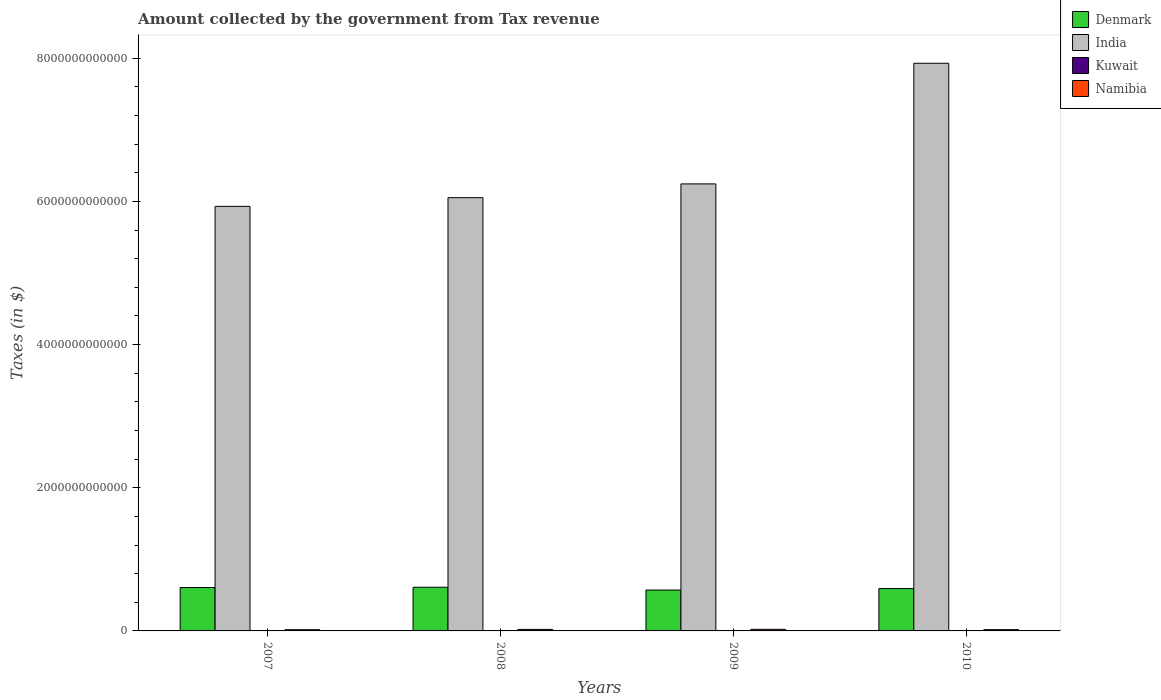How many groups of bars are there?
Give a very brief answer. 4. Are the number of bars per tick equal to the number of legend labels?
Your answer should be very brief. Yes. Are the number of bars on each tick of the X-axis equal?
Offer a very short reply. Yes. How many bars are there on the 2nd tick from the right?
Give a very brief answer. 4. What is the label of the 1st group of bars from the left?
Offer a terse response. 2007. In how many cases, is the number of bars for a given year not equal to the number of legend labels?
Your response must be concise. 0. What is the amount collected by the government from tax revenue in Kuwait in 2007?
Make the answer very short. 3.54e+08. Across all years, what is the maximum amount collected by the government from tax revenue in India?
Your response must be concise. 7.93e+12. Across all years, what is the minimum amount collected by the government from tax revenue in Kuwait?
Give a very brief answer. 2.96e+08. What is the total amount collected by the government from tax revenue in Kuwait in the graph?
Ensure brevity in your answer.  1.32e+09. What is the difference between the amount collected by the government from tax revenue in Namibia in 2007 and that in 2010?
Your answer should be compact. -9.67e+08. What is the difference between the amount collected by the government from tax revenue in Denmark in 2008 and the amount collected by the government from tax revenue in Namibia in 2010?
Provide a short and direct response. 5.92e+11. What is the average amount collected by the government from tax revenue in Namibia per year?
Provide a short and direct response. 1.96e+1. In the year 2008, what is the difference between the amount collected by the government from tax revenue in Kuwait and amount collected by the government from tax revenue in India?
Keep it short and to the point. -6.05e+12. In how many years, is the amount collected by the government from tax revenue in Namibia greater than 2000000000000 $?
Ensure brevity in your answer.  0. What is the ratio of the amount collected by the government from tax revenue in Denmark in 2008 to that in 2010?
Give a very brief answer. 1.03. Is the difference between the amount collected by the government from tax revenue in Kuwait in 2009 and 2010 greater than the difference between the amount collected by the government from tax revenue in India in 2009 and 2010?
Provide a succinct answer. Yes. What is the difference between the highest and the second highest amount collected by the government from tax revenue in Namibia?
Your answer should be very brief. 1.05e+09. What is the difference between the highest and the lowest amount collected by the government from tax revenue in India?
Your answer should be compact. 2.00e+12. What does the 3rd bar from the left in 2009 represents?
Provide a succinct answer. Kuwait. Are all the bars in the graph horizontal?
Ensure brevity in your answer.  No. What is the difference between two consecutive major ticks on the Y-axis?
Give a very brief answer. 2.00e+12. Does the graph contain grids?
Make the answer very short. No. How many legend labels are there?
Your answer should be compact. 4. What is the title of the graph?
Ensure brevity in your answer.  Amount collected by the government from Tax revenue. What is the label or title of the Y-axis?
Provide a succinct answer. Taxes (in $). What is the Taxes (in $) in Denmark in 2007?
Provide a succinct answer. 6.07e+11. What is the Taxes (in $) in India in 2007?
Keep it short and to the point. 5.93e+12. What is the Taxes (in $) in Kuwait in 2007?
Your answer should be very brief. 3.54e+08. What is the Taxes (in $) of Namibia in 2007?
Offer a very short reply. 1.70e+1. What is the Taxes (in $) in Denmark in 2008?
Offer a terse response. 6.10e+11. What is the Taxes (in $) of India in 2008?
Offer a very short reply. 6.05e+12. What is the Taxes (in $) in Kuwait in 2008?
Offer a terse response. 3.47e+08. What is the Taxes (in $) in Namibia in 2008?
Your answer should be very brief. 2.12e+1. What is the Taxes (in $) of Denmark in 2009?
Ensure brevity in your answer.  5.71e+11. What is the Taxes (in $) in India in 2009?
Provide a short and direct response. 6.25e+12. What is the Taxes (in $) in Kuwait in 2009?
Make the answer very short. 2.96e+08. What is the Taxes (in $) of Namibia in 2009?
Provide a short and direct response. 2.23e+1. What is the Taxes (in $) of Denmark in 2010?
Your response must be concise. 5.91e+11. What is the Taxes (in $) of India in 2010?
Make the answer very short. 7.93e+12. What is the Taxes (in $) in Kuwait in 2010?
Offer a terse response. 3.24e+08. What is the Taxes (in $) in Namibia in 2010?
Keep it short and to the point. 1.79e+1. Across all years, what is the maximum Taxes (in $) of Denmark?
Make the answer very short. 6.10e+11. Across all years, what is the maximum Taxes (in $) of India?
Your response must be concise. 7.93e+12. Across all years, what is the maximum Taxes (in $) of Kuwait?
Keep it short and to the point. 3.54e+08. Across all years, what is the maximum Taxes (in $) of Namibia?
Ensure brevity in your answer.  2.23e+1. Across all years, what is the minimum Taxes (in $) of Denmark?
Your answer should be compact. 5.71e+11. Across all years, what is the minimum Taxes (in $) in India?
Your answer should be very brief. 5.93e+12. Across all years, what is the minimum Taxes (in $) of Kuwait?
Your response must be concise. 2.96e+08. Across all years, what is the minimum Taxes (in $) in Namibia?
Offer a very short reply. 1.70e+1. What is the total Taxes (in $) in Denmark in the graph?
Make the answer very short. 2.38e+12. What is the total Taxes (in $) of India in the graph?
Offer a terse response. 2.62e+13. What is the total Taxes (in $) of Kuwait in the graph?
Give a very brief answer. 1.32e+09. What is the total Taxes (in $) of Namibia in the graph?
Your answer should be compact. 7.84e+1. What is the difference between the Taxes (in $) in Denmark in 2007 and that in 2008?
Your response must be concise. -3.56e+09. What is the difference between the Taxes (in $) of India in 2007 and that in 2008?
Ensure brevity in your answer.  -1.22e+11. What is the difference between the Taxes (in $) in Namibia in 2007 and that in 2008?
Keep it short and to the point. -4.25e+09. What is the difference between the Taxes (in $) of Denmark in 2007 and that in 2009?
Keep it short and to the point. 3.54e+1. What is the difference between the Taxes (in $) of India in 2007 and that in 2009?
Ensure brevity in your answer.  -3.14e+11. What is the difference between the Taxes (in $) in Kuwait in 2007 and that in 2009?
Offer a very short reply. 5.80e+07. What is the difference between the Taxes (in $) in Namibia in 2007 and that in 2009?
Your answer should be very brief. -5.30e+09. What is the difference between the Taxes (in $) of Denmark in 2007 and that in 2010?
Offer a terse response. 1.51e+1. What is the difference between the Taxes (in $) of India in 2007 and that in 2010?
Keep it short and to the point. -2.00e+12. What is the difference between the Taxes (in $) in Kuwait in 2007 and that in 2010?
Provide a short and direct response. 3.00e+07. What is the difference between the Taxes (in $) of Namibia in 2007 and that in 2010?
Make the answer very short. -9.67e+08. What is the difference between the Taxes (in $) in Denmark in 2008 and that in 2009?
Ensure brevity in your answer.  3.89e+1. What is the difference between the Taxes (in $) of India in 2008 and that in 2009?
Provide a short and direct response. -1.92e+11. What is the difference between the Taxes (in $) in Kuwait in 2008 and that in 2009?
Provide a succinct answer. 5.10e+07. What is the difference between the Taxes (in $) in Namibia in 2008 and that in 2009?
Your response must be concise. -1.05e+09. What is the difference between the Taxes (in $) in Denmark in 2008 and that in 2010?
Provide a succinct answer. 1.87e+1. What is the difference between the Taxes (in $) of India in 2008 and that in 2010?
Keep it short and to the point. -1.88e+12. What is the difference between the Taxes (in $) of Kuwait in 2008 and that in 2010?
Provide a succinct answer. 2.30e+07. What is the difference between the Taxes (in $) of Namibia in 2008 and that in 2010?
Provide a short and direct response. 3.29e+09. What is the difference between the Taxes (in $) of Denmark in 2009 and that in 2010?
Provide a short and direct response. -2.03e+1. What is the difference between the Taxes (in $) in India in 2009 and that in 2010?
Your answer should be compact. -1.69e+12. What is the difference between the Taxes (in $) in Kuwait in 2009 and that in 2010?
Make the answer very short. -2.80e+07. What is the difference between the Taxes (in $) of Namibia in 2009 and that in 2010?
Give a very brief answer. 4.34e+09. What is the difference between the Taxes (in $) in Denmark in 2007 and the Taxes (in $) in India in 2008?
Keep it short and to the point. -5.45e+12. What is the difference between the Taxes (in $) of Denmark in 2007 and the Taxes (in $) of Kuwait in 2008?
Your answer should be very brief. 6.06e+11. What is the difference between the Taxes (in $) of Denmark in 2007 and the Taxes (in $) of Namibia in 2008?
Give a very brief answer. 5.85e+11. What is the difference between the Taxes (in $) in India in 2007 and the Taxes (in $) in Kuwait in 2008?
Provide a succinct answer. 5.93e+12. What is the difference between the Taxes (in $) in India in 2007 and the Taxes (in $) in Namibia in 2008?
Keep it short and to the point. 5.91e+12. What is the difference between the Taxes (in $) in Kuwait in 2007 and the Taxes (in $) in Namibia in 2008?
Ensure brevity in your answer.  -2.09e+1. What is the difference between the Taxes (in $) of Denmark in 2007 and the Taxes (in $) of India in 2009?
Provide a succinct answer. -5.64e+12. What is the difference between the Taxes (in $) of Denmark in 2007 and the Taxes (in $) of Kuwait in 2009?
Your response must be concise. 6.06e+11. What is the difference between the Taxes (in $) in Denmark in 2007 and the Taxes (in $) in Namibia in 2009?
Keep it short and to the point. 5.84e+11. What is the difference between the Taxes (in $) of India in 2007 and the Taxes (in $) of Kuwait in 2009?
Your response must be concise. 5.93e+12. What is the difference between the Taxes (in $) in India in 2007 and the Taxes (in $) in Namibia in 2009?
Your answer should be very brief. 5.91e+12. What is the difference between the Taxes (in $) of Kuwait in 2007 and the Taxes (in $) of Namibia in 2009?
Provide a succinct answer. -2.19e+1. What is the difference between the Taxes (in $) in Denmark in 2007 and the Taxes (in $) in India in 2010?
Ensure brevity in your answer.  -7.32e+12. What is the difference between the Taxes (in $) of Denmark in 2007 and the Taxes (in $) of Kuwait in 2010?
Your response must be concise. 6.06e+11. What is the difference between the Taxes (in $) in Denmark in 2007 and the Taxes (in $) in Namibia in 2010?
Your answer should be very brief. 5.89e+11. What is the difference between the Taxes (in $) in India in 2007 and the Taxes (in $) in Kuwait in 2010?
Give a very brief answer. 5.93e+12. What is the difference between the Taxes (in $) in India in 2007 and the Taxes (in $) in Namibia in 2010?
Provide a short and direct response. 5.91e+12. What is the difference between the Taxes (in $) of Kuwait in 2007 and the Taxes (in $) of Namibia in 2010?
Make the answer very short. -1.76e+1. What is the difference between the Taxes (in $) in Denmark in 2008 and the Taxes (in $) in India in 2009?
Give a very brief answer. -5.64e+12. What is the difference between the Taxes (in $) in Denmark in 2008 and the Taxes (in $) in Kuwait in 2009?
Ensure brevity in your answer.  6.10e+11. What is the difference between the Taxes (in $) of Denmark in 2008 and the Taxes (in $) of Namibia in 2009?
Offer a terse response. 5.88e+11. What is the difference between the Taxes (in $) in India in 2008 and the Taxes (in $) in Kuwait in 2009?
Give a very brief answer. 6.05e+12. What is the difference between the Taxes (in $) of India in 2008 and the Taxes (in $) of Namibia in 2009?
Your answer should be compact. 6.03e+12. What is the difference between the Taxes (in $) of Kuwait in 2008 and the Taxes (in $) of Namibia in 2009?
Offer a very short reply. -2.19e+1. What is the difference between the Taxes (in $) in Denmark in 2008 and the Taxes (in $) in India in 2010?
Your answer should be compact. -7.32e+12. What is the difference between the Taxes (in $) of Denmark in 2008 and the Taxes (in $) of Kuwait in 2010?
Your response must be concise. 6.10e+11. What is the difference between the Taxes (in $) of Denmark in 2008 and the Taxes (in $) of Namibia in 2010?
Provide a short and direct response. 5.92e+11. What is the difference between the Taxes (in $) of India in 2008 and the Taxes (in $) of Kuwait in 2010?
Provide a succinct answer. 6.05e+12. What is the difference between the Taxes (in $) in India in 2008 and the Taxes (in $) in Namibia in 2010?
Your answer should be compact. 6.04e+12. What is the difference between the Taxes (in $) in Kuwait in 2008 and the Taxes (in $) in Namibia in 2010?
Make the answer very short. -1.76e+1. What is the difference between the Taxes (in $) of Denmark in 2009 and the Taxes (in $) of India in 2010?
Your answer should be very brief. -7.36e+12. What is the difference between the Taxes (in $) in Denmark in 2009 and the Taxes (in $) in Kuwait in 2010?
Your response must be concise. 5.71e+11. What is the difference between the Taxes (in $) in Denmark in 2009 and the Taxes (in $) in Namibia in 2010?
Your answer should be very brief. 5.53e+11. What is the difference between the Taxes (in $) in India in 2009 and the Taxes (in $) in Kuwait in 2010?
Your answer should be compact. 6.24e+12. What is the difference between the Taxes (in $) of India in 2009 and the Taxes (in $) of Namibia in 2010?
Keep it short and to the point. 6.23e+12. What is the difference between the Taxes (in $) in Kuwait in 2009 and the Taxes (in $) in Namibia in 2010?
Keep it short and to the point. -1.76e+1. What is the average Taxes (in $) of Denmark per year?
Your response must be concise. 5.95e+11. What is the average Taxes (in $) of India per year?
Your response must be concise. 6.54e+12. What is the average Taxes (in $) in Kuwait per year?
Provide a short and direct response. 3.30e+08. What is the average Taxes (in $) in Namibia per year?
Provide a succinct answer. 1.96e+1. In the year 2007, what is the difference between the Taxes (in $) of Denmark and Taxes (in $) of India?
Offer a very short reply. -5.32e+12. In the year 2007, what is the difference between the Taxes (in $) in Denmark and Taxes (in $) in Kuwait?
Make the answer very short. 6.06e+11. In the year 2007, what is the difference between the Taxes (in $) in Denmark and Taxes (in $) in Namibia?
Give a very brief answer. 5.90e+11. In the year 2007, what is the difference between the Taxes (in $) of India and Taxes (in $) of Kuwait?
Provide a short and direct response. 5.93e+12. In the year 2007, what is the difference between the Taxes (in $) in India and Taxes (in $) in Namibia?
Ensure brevity in your answer.  5.91e+12. In the year 2007, what is the difference between the Taxes (in $) of Kuwait and Taxes (in $) of Namibia?
Give a very brief answer. -1.66e+1. In the year 2008, what is the difference between the Taxes (in $) of Denmark and Taxes (in $) of India?
Your answer should be very brief. -5.44e+12. In the year 2008, what is the difference between the Taxes (in $) of Denmark and Taxes (in $) of Kuwait?
Offer a very short reply. 6.10e+11. In the year 2008, what is the difference between the Taxes (in $) in Denmark and Taxes (in $) in Namibia?
Your response must be concise. 5.89e+11. In the year 2008, what is the difference between the Taxes (in $) of India and Taxes (in $) of Kuwait?
Offer a very short reply. 6.05e+12. In the year 2008, what is the difference between the Taxes (in $) of India and Taxes (in $) of Namibia?
Provide a succinct answer. 6.03e+12. In the year 2008, what is the difference between the Taxes (in $) of Kuwait and Taxes (in $) of Namibia?
Offer a very short reply. -2.09e+1. In the year 2009, what is the difference between the Taxes (in $) of Denmark and Taxes (in $) of India?
Your answer should be very brief. -5.67e+12. In the year 2009, what is the difference between the Taxes (in $) in Denmark and Taxes (in $) in Kuwait?
Your answer should be compact. 5.71e+11. In the year 2009, what is the difference between the Taxes (in $) in Denmark and Taxes (in $) in Namibia?
Make the answer very short. 5.49e+11. In the year 2009, what is the difference between the Taxes (in $) of India and Taxes (in $) of Kuwait?
Keep it short and to the point. 6.24e+12. In the year 2009, what is the difference between the Taxes (in $) of India and Taxes (in $) of Namibia?
Give a very brief answer. 6.22e+12. In the year 2009, what is the difference between the Taxes (in $) of Kuwait and Taxes (in $) of Namibia?
Keep it short and to the point. -2.20e+1. In the year 2010, what is the difference between the Taxes (in $) in Denmark and Taxes (in $) in India?
Offer a terse response. -7.34e+12. In the year 2010, what is the difference between the Taxes (in $) of Denmark and Taxes (in $) of Kuwait?
Provide a short and direct response. 5.91e+11. In the year 2010, what is the difference between the Taxes (in $) in Denmark and Taxes (in $) in Namibia?
Provide a short and direct response. 5.74e+11. In the year 2010, what is the difference between the Taxes (in $) in India and Taxes (in $) in Kuwait?
Make the answer very short. 7.93e+12. In the year 2010, what is the difference between the Taxes (in $) of India and Taxes (in $) of Namibia?
Keep it short and to the point. 7.91e+12. In the year 2010, what is the difference between the Taxes (in $) in Kuwait and Taxes (in $) in Namibia?
Offer a very short reply. -1.76e+1. What is the ratio of the Taxes (in $) of Denmark in 2007 to that in 2008?
Provide a succinct answer. 0.99. What is the ratio of the Taxes (in $) of India in 2007 to that in 2008?
Your response must be concise. 0.98. What is the ratio of the Taxes (in $) in Kuwait in 2007 to that in 2008?
Provide a short and direct response. 1.02. What is the ratio of the Taxes (in $) of Namibia in 2007 to that in 2008?
Offer a very short reply. 0.8. What is the ratio of the Taxes (in $) of Denmark in 2007 to that in 2009?
Keep it short and to the point. 1.06. What is the ratio of the Taxes (in $) in India in 2007 to that in 2009?
Your response must be concise. 0.95. What is the ratio of the Taxes (in $) of Kuwait in 2007 to that in 2009?
Make the answer very short. 1.2. What is the ratio of the Taxes (in $) of Namibia in 2007 to that in 2009?
Your answer should be very brief. 0.76. What is the ratio of the Taxes (in $) in Denmark in 2007 to that in 2010?
Keep it short and to the point. 1.03. What is the ratio of the Taxes (in $) of India in 2007 to that in 2010?
Provide a short and direct response. 0.75. What is the ratio of the Taxes (in $) in Kuwait in 2007 to that in 2010?
Ensure brevity in your answer.  1.09. What is the ratio of the Taxes (in $) of Namibia in 2007 to that in 2010?
Offer a very short reply. 0.95. What is the ratio of the Taxes (in $) of Denmark in 2008 to that in 2009?
Offer a terse response. 1.07. What is the ratio of the Taxes (in $) of India in 2008 to that in 2009?
Your answer should be very brief. 0.97. What is the ratio of the Taxes (in $) in Kuwait in 2008 to that in 2009?
Give a very brief answer. 1.17. What is the ratio of the Taxes (in $) in Namibia in 2008 to that in 2009?
Ensure brevity in your answer.  0.95. What is the ratio of the Taxes (in $) in Denmark in 2008 to that in 2010?
Offer a very short reply. 1.03. What is the ratio of the Taxes (in $) in India in 2008 to that in 2010?
Make the answer very short. 0.76. What is the ratio of the Taxes (in $) in Kuwait in 2008 to that in 2010?
Your answer should be compact. 1.07. What is the ratio of the Taxes (in $) in Namibia in 2008 to that in 2010?
Ensure brevity in your answer.  1.18. What is the ratio of the Taxes (in $) in Denmark in 2009 to that in 2010?
Your answer should be very brief. 0.97. What is the ratio of the Taxes (in $) in India in 2009 to that in 2010?
Provide a succinct answer. 0.79. What is the ratio of the Taxes (in $) of Kuwait in 2009 to that in 2010?
Keep it short and to the point. 0.91. What is the ratio of the Taxes (in $) in Namibia in 2009 to that in 2010?
Your answer should be very brief. 1.24. What is the difference between the highest and the second highest Taxes (in $) of Denmark?
Provide a short and direct response. 3.56e+09. What is the difference between the highest and the second highest Taxes (in $) of India?
Your answer should be very brief. 1.69e+12. What is the difference between the highest and the second highest Taxes (in $) in Kuwait?
Your response must be concise. 7.00e+06. What is the difference between the highest and the second highest Taxes (in $) of Namibia?
Offer a very short reply. 1.05e+09. What is the difference between the highest and the lowest Taxes (in $) in Denmark?
Offer a very short reply. 3.89e+1. What is the difference between the highest and the lowest Taxes (in $) of India?
Keep it short and to the point. 2.00e+12. What is the difference between the highest and the lowest Taxes (in $) in Kuwait?
Your answer should be compact. 5.80e+07. What is the difference between the highest and the lowest Taxes (in $) of Namibia?
Ensure brevity in your answer.  5.30e+09. 